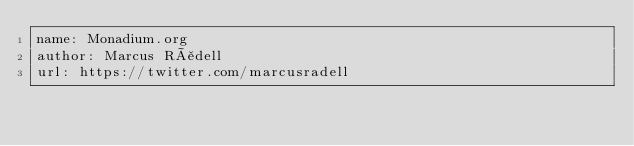Convert code to text. <code><loc_0><loc_0><loc_500><loc_500><_YAML_>name: Monadium.org
author: Marcus Rådell
url: https://twitter.com/marcusradell
</code> 